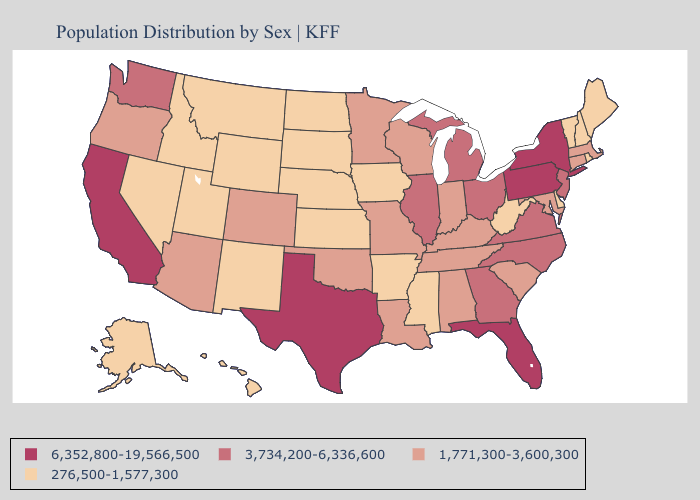Does the map have missing data?
Short answer required. No. What is the highest value in the Northeast ?
Write a very short answer. 6,352,800-19,566,500. Which states have the highest value in the USA?
Short answer required. California, Florida, New York, Pennsylvania, Texas. Name the states that have a value in the range 3,734,200-6,336,600?
Be succinct. Georgia, Illinois, Michigan, New Jersey, North Carolina, Ohio, Virginia, Washington. Which states have the lowest value in the South?
Keep it brief. Arkansas, Delaware, Mississippi, West Virginia. Does Georgia have the highest value in the South?
Give a very brief answer. No. Name the states that have a value in the range 3,734,200-6,336,600?
Concise answer only. Georgia, Illinois, Michigan, New Jersey, North Carolina, Ohio, Virginia, Washington. Name the states that have a value in the range 276,500-1,577,300?
Write a very short answer. Alaska, Arkansas, Delaware, Hawaii, Idaho, Iowa, Kansas, Maine, Mississippi, Montana, Nebraska, Nevada, New Hampshire, New Mexico, North Dakota, Rhode Island, South Dakota, Utah, Vermont, West Virginia, Wyoming. Among the states that border New York , does Pennsylvania have the highest value?
Answer briefly. Yes. What is the lowest value in states that border South Dakota?
Short answer required. 276,500-1,577,300. What is the lowest value in the USA?
Write a very short answer. 276,500-1,577,300. Name the states that have a value in the range 6,352,800-19,566,500?
Be succinct. California, Florida, New York, Pennsylvania, Texas. What is the lowest value in the USA?
Write a very short answer. 276,500-1,577,300. What is the value of South Dakota?
Keep it brief. 276,500-1,577,300. Name the states that have a value in the range 1,771,300-3,600,300?
Be succinct. Alabama, Arizona, Colorado, Connecticut, Indiana, Kentucky, Louisiana, Maryland, Massachusetts, Minnesota, Missouri, Oklahoma, Oregon, South Carolina, Tennessee, Wisconsin. 